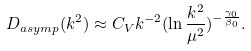Convert formula to latex. <formula><loc_0><loc_0><loc_500><loc_500>D _ { a s y m p } ( k ^ { 2 } ) \approx C _ { V } k ^ { - 2 } ( \ln { \frac { k ^ { 2 } } { { \mu } ^ { 2 } } } ) ^ { - \frac { { \gamma } _ { 0 } } { { \beta } _ { 0 } } } .</formula> 